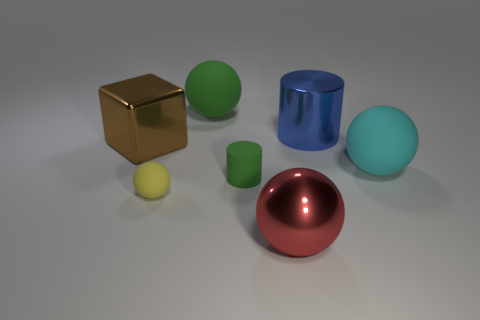Add 1 large rubber cylinders. How many objects exist? 8 Subtract all cylinders. How many objects are left? 5 Add 5 green matte cylinders. How many green matte cylinders exist? 6 Subtract 0 yellow cylinders. How many objects are left? 7 Subtract all yellow cubes. Subtract all big metal cubes. How many objects are left? 6 Add 7 red metallic things. How many red metallic things are left? 8 